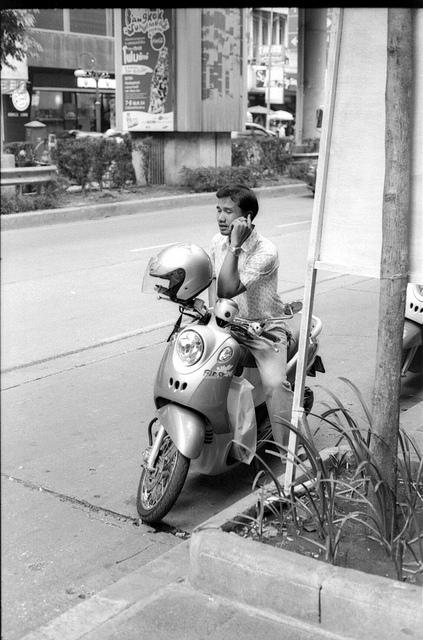Is the man wearing a hat?
Be succinct. No. What is the man doing?
Be succinct. Talking on phone. Is the man indoors?
Give a very brief answer. No. 